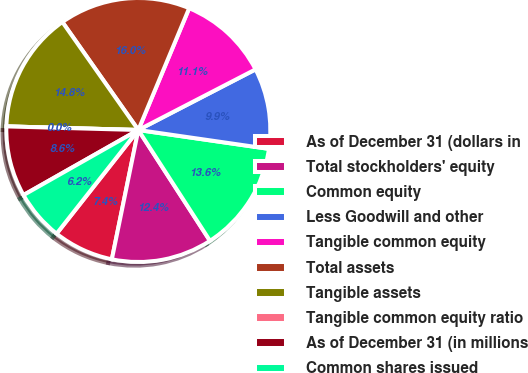Convert chart to OTSL. <chart><loc_0><loc_0><loc_500><loc_500><pie_chart><fcel>As of December 31 (dollars in<fcel>Total stockholders' equity<fcel>Common equity<fcel>Less Goodwill and other<fcel>Tangible common equity<fcel>Total assets<fcel>Tangible assets<fcel>Tangible common equity ratio<fcel>As of December 31 (in millions<fcel>Common shares issued<nl><fcel>7.41%<fcel>12.35%<fcel>13.58%<fcel>9.88%<fcel>11.11%<fcel>16.05%<fcel>14.81%<fcel>0.0%<fcel>8.64%<fcel>6.17%<nl></chart> 